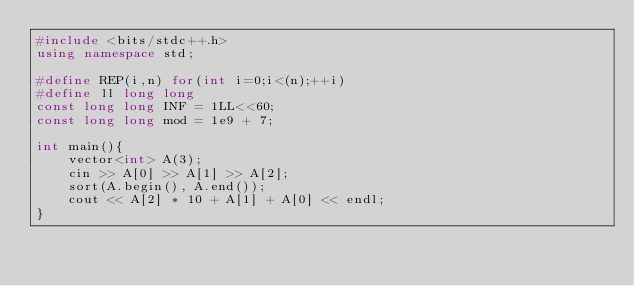<code> <loc_0><loc_0><loc_500><loc_500><_C++_>#include <bits/stdc++.h>
using namespace std;

#define REP(i,n) for(int i=0;i<(n);++i)
#define ll long long
const long long INF = 1LL<<60;
const long long mod = 1e9 + 7;

int main(){
    vector<int> A(3);
    cin >> A[0] >> A[1] >> A[2];
    sort(A.begin(), A.end());
    cout << A[2] * 10 + A[1] + A[0] << endl;
}</code> 